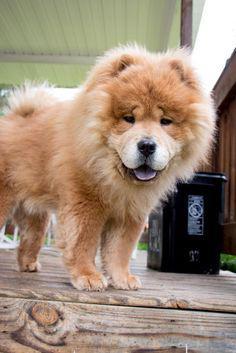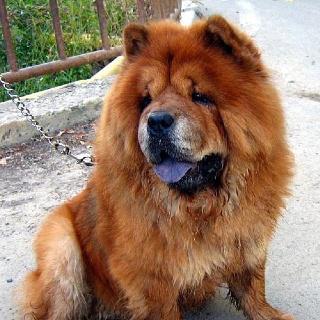The first image is the image on the left, the second image is the image on the right. Evaluate the accuracy of this statement regarding the images: "One of the images contains a dog that is laying down.". Is it true? Answer yes or no. No. 